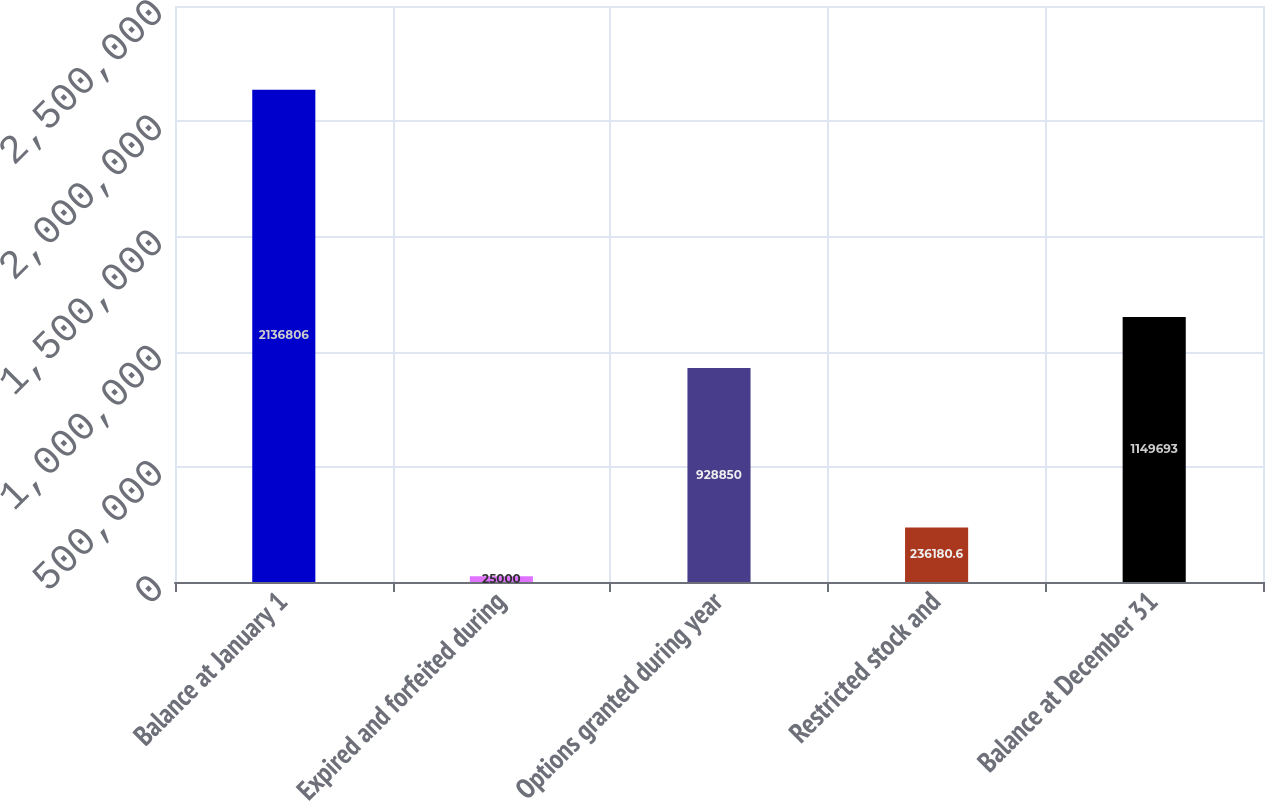Convert chart to OTSL. <chart><loc_0><loc_0><loc_500><loc_500><bar_chart><fcel>Balance at January 1<fcel>Expired and forfeited during<fcel>Options granted during year<fcel>Restricted stock and<fcel>Balance at December 31<nl><fcel>2.13681e+06<fcel>25000<fcel>928850<fcel>236181<fcel>1.14969e+06<nl></chart> 